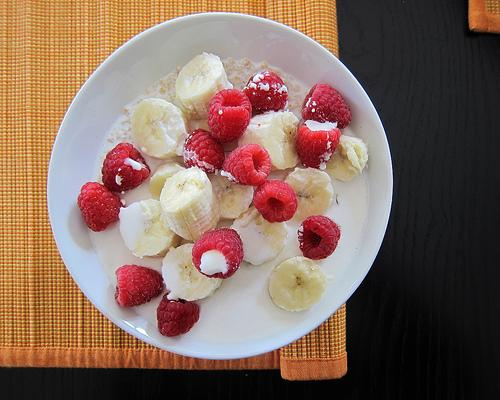What type of fruits can be seen in the image? The image contains sliced bananas and red raspberries. Write a poetic description of the image. A symphony of flavors entwined, where slices of bananas and raspberries divine, rest upon a serene pool of milk so white, settled on a woven mat so bright. Provide a brief description of the main components in the image. A bowl of fruit in milk placed on an orange placemat, with sliced bananas and red raspberries floating inside the white milk. Use the image as inspiration and write an advertising slogan for a cereal brand. Taste the morning sunshine with every spoonful of our banana-raspberry delight! List the objects contained in the image. Bowl, milk, sliced bananas, red raspberries, orange placemat, and wooden table. Write a headline for a magazine article featuring this image. Fruity Delights: The Perfect Blend of Bananas and Raspberries in a Bowl of Milk Briefly describe the color scheme and objects in the image. The image features a white bowl of milk with bananas and raspberries, placed on an orange woven fabric placemat on top of a black painted wooden table. Mention two colors that are prominently visible in the image. White and orange colors are prominently visible in the image. Describe the texture and material of the main elements in the image. The smooth, white milk contrasts with the soft, fleshy banana chunks and the slightly bumpy, red raspberries in the bowl, all placed on a woven, fabric placemat. Imagine this image as a painting, and describe its composition. A still life capturing the essence of breakfast, with a white bowl of milk enriched with banana slices and red raspberries, elegantly placed on an orange placemat, contrasting the dark table backdrop. 